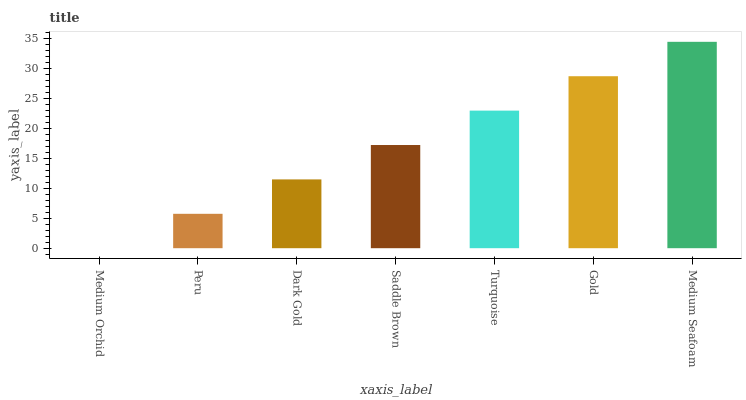Is Medium Orchid the minimum?
Answer yes or no. Yes. Is Medium Seafoam the maximum?
Answer yes or no. Yes. Is Peru the minimum?
Answer yes or no. No. Is Peru the maximum?
Answer yes or no. No. Is Peru greater than Medium Orchid?
Answer yes or no. Yes. Is Medium Orchid less than Peru?
Answer yes or no. Yes. Is Medium Orchid greater than Peru?
Answer yes or no. No. Is Peru less than Medium Orchid?
Answer yes or no. No. Is Saddle Brown the high median?
Answer yes or no. Yes. Is Saddle Brown the low median?
Answer yes or no. Yes. Is Turquoise the high median?
Answer yes or no. No. Is Turquoise the low median?
Answer yes or no. No. 